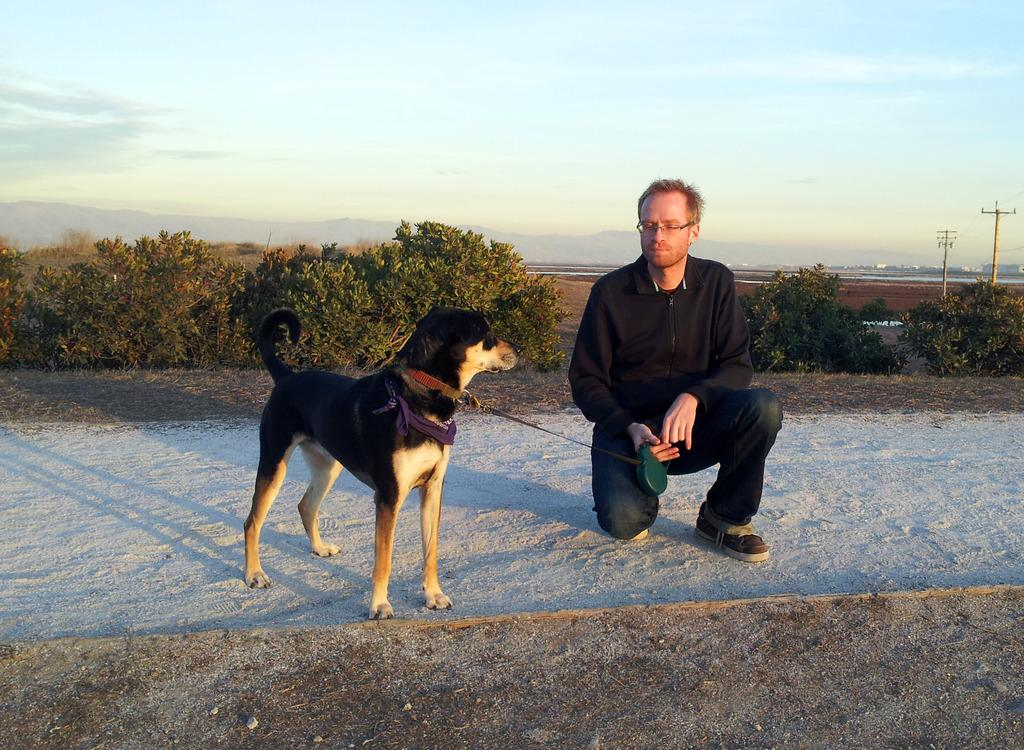What is the main subject of the image? The main subject of the image is a man. What is the man doing in the image? The man is sitting in the image. What other living creature is present in the image? There is a dog in the image. Where is the dog located in relation to the man? The dog is beside the man in the image. What type of bubble can be seen floating around the man in the image? There is no bubble present in the image. What emotion does the man appear to be expressing in the image? The provided facts do not mention any specific emotion being expressed by the man. 